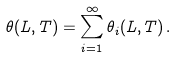Convert formula to latex. <formula><loc_0><loc_0><loc_500><loc_500>\theta ( L , T ) = \sum _ { i = 1 } ^ { \infty } \theta _ { i } ( L , T ) \, .</formula> 